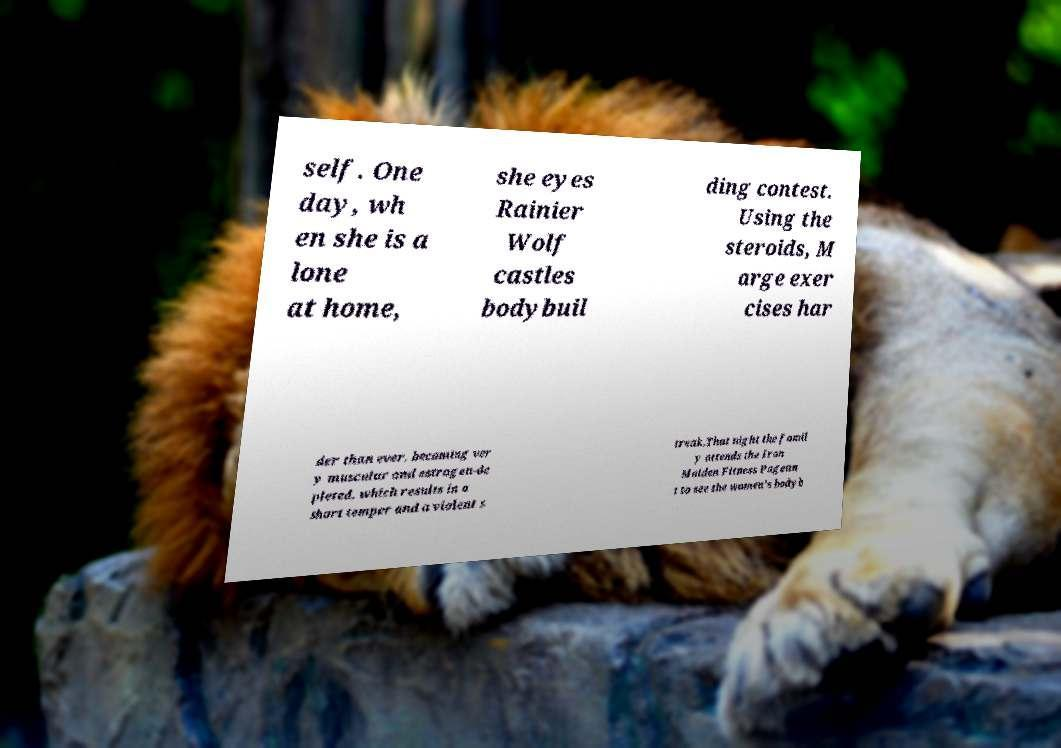There's text embedded in this image that I need extracted. Can you transcribe it verbatim? self. One day, wh en she is a lone at home, she eyes Rainier Wolf castles bodybuil ding contest. Using the steroids, M arge exer cises har der than ever, becoming ver y muscular and estrogen-de pleted, which results in a short temper and a violent s treak.That night the famil y attends the Iron Maiden Fitness Pagean t to see the women's bodyb 